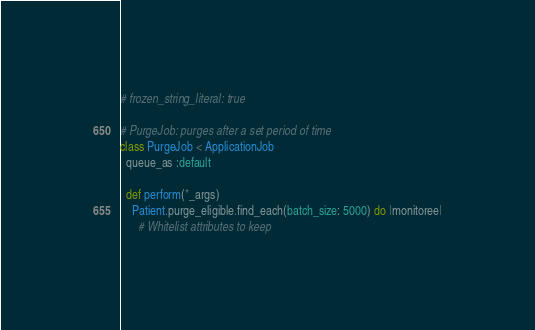Convert code to text. <code><loc_0><loc_0><loc_500><loc_500><_Ruby_># frozen_string_literal: true

# PurgeJob: purges after a set period of time
class PurgeJob < ApplicationJob
  queue_as :default

  def perform(*_args)
    Patient.purge_eligible.find_each(batch_size: 5000) do |monitoree|
      # Whitelist attributes to keep</code> 